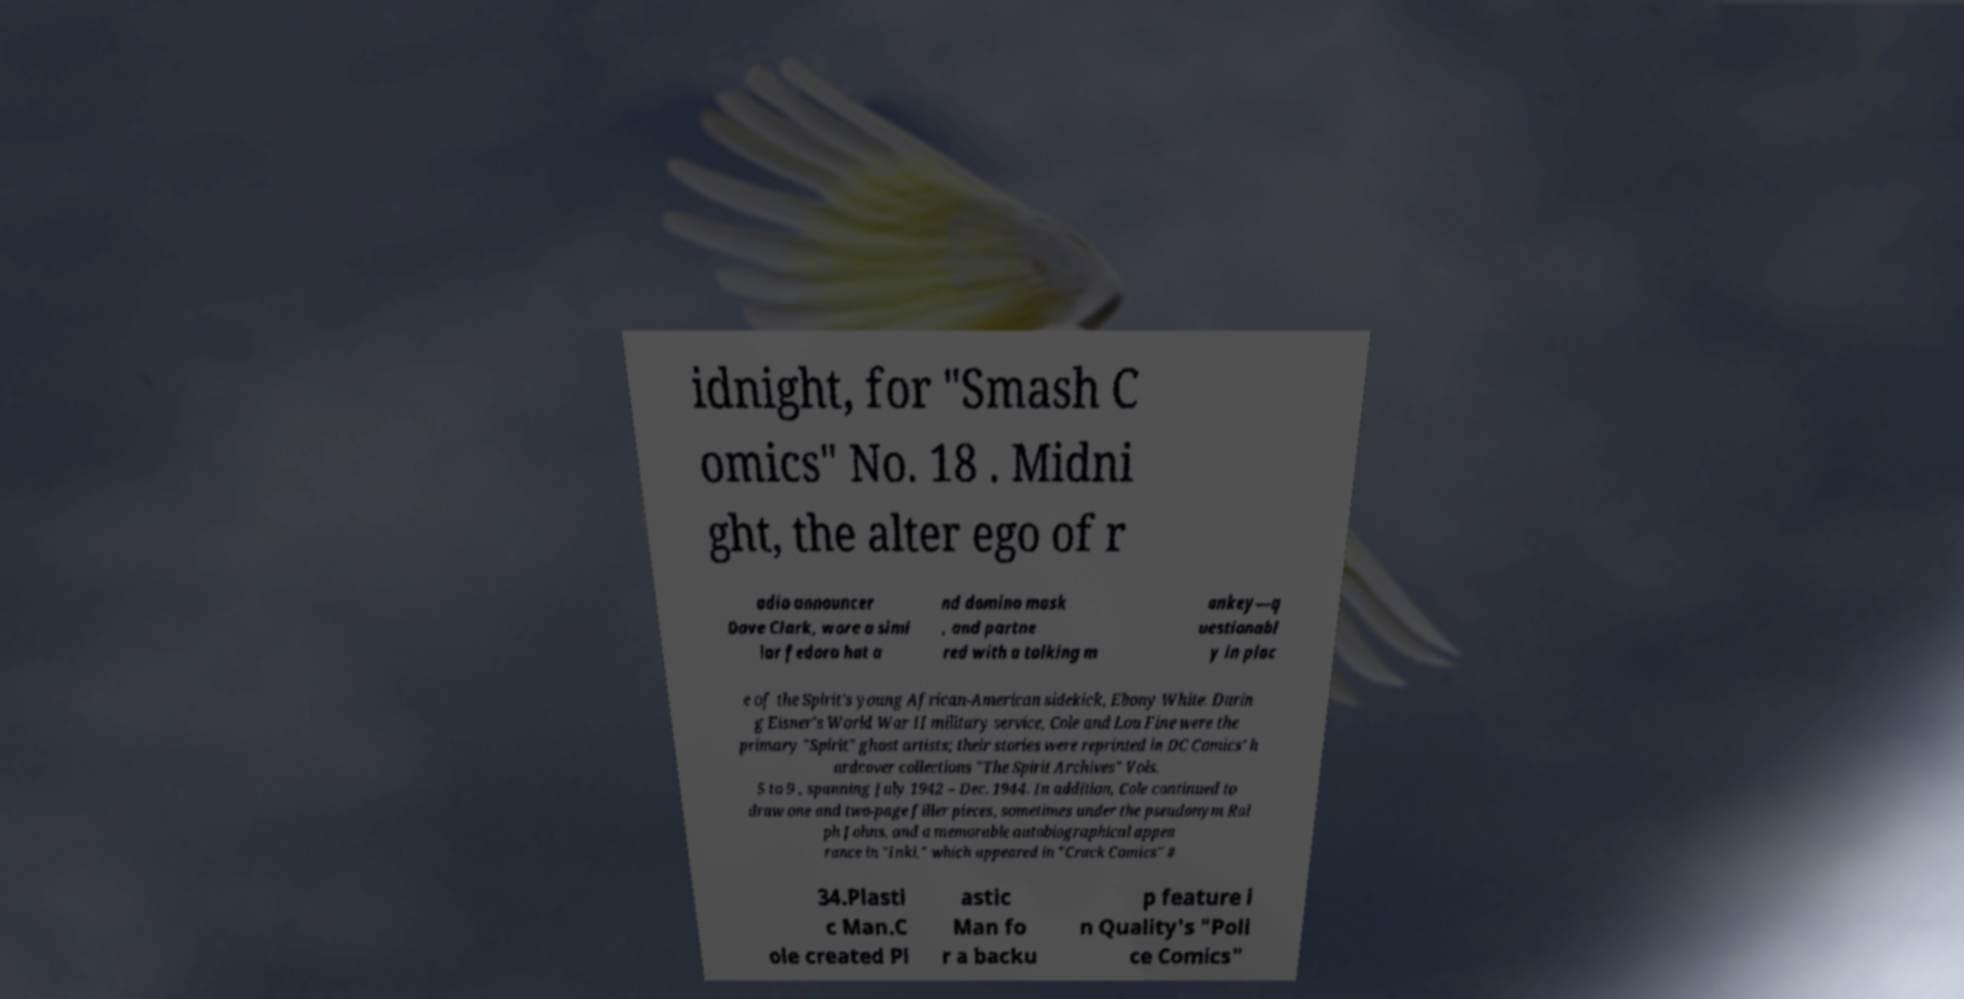Please read and relay the text visible in this image. What does it say? idnight, for "Smash C omics" No. 18 . Midni ght, the alter ego of r adio announcer Dave Clark, wore a simi lar fedora hat a nd domino mask , and partne red with a talking m onkey—q uestionabl y in plac e of the Spirit's young African-American sidekick, Ebony White. Durin g Eisner's World War II military service, Cole and Lou Fine were the primary "Spirit" ghost artists; their stories were reprinted in DC Comics' h ardcover collections "The Spirit Archives" Vols. 5 to 9 , spanning July 1942 – Dec. 1944. In addition, Cole continued to draw one and two-page filler pieces, sometimes under the pseudonym Ral ph Johns, and a memorable autobiographical appea rance in "Inki," which appeared in "Crack Comics" # 34.Plasti c Man.C ole created Pl astic Man fo r a backu p feature i n Quality's "Poli ce Comics" 